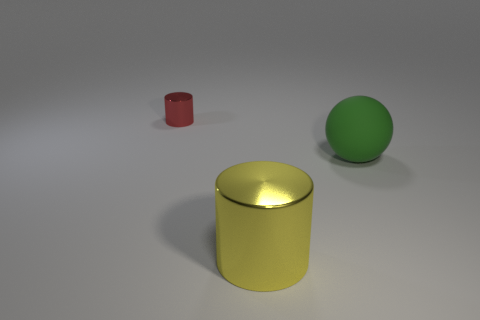Subtract 2 cylinders. How many cylinders are left? 0 Subtract all blue cylinders. Subtract all yellow spheres. How many cylinders are left? 2 Subtract all green blocks. How many red cylinders are left? 1 Subtract all big yellow cylinders. Subtract all small green shiny balls. How many objects are left? 2 Add 2 large metallic cylinders. How many large metallic cylinders are left? 3 Add 2 big metal cylinders. How many big metal cylinders exist? 3 Add 1 yellow things. How many objects exist? 4 Subtract 0 red blocks. How many objects are left? 3 Subtract all cylinders. How many objects are left? 1 